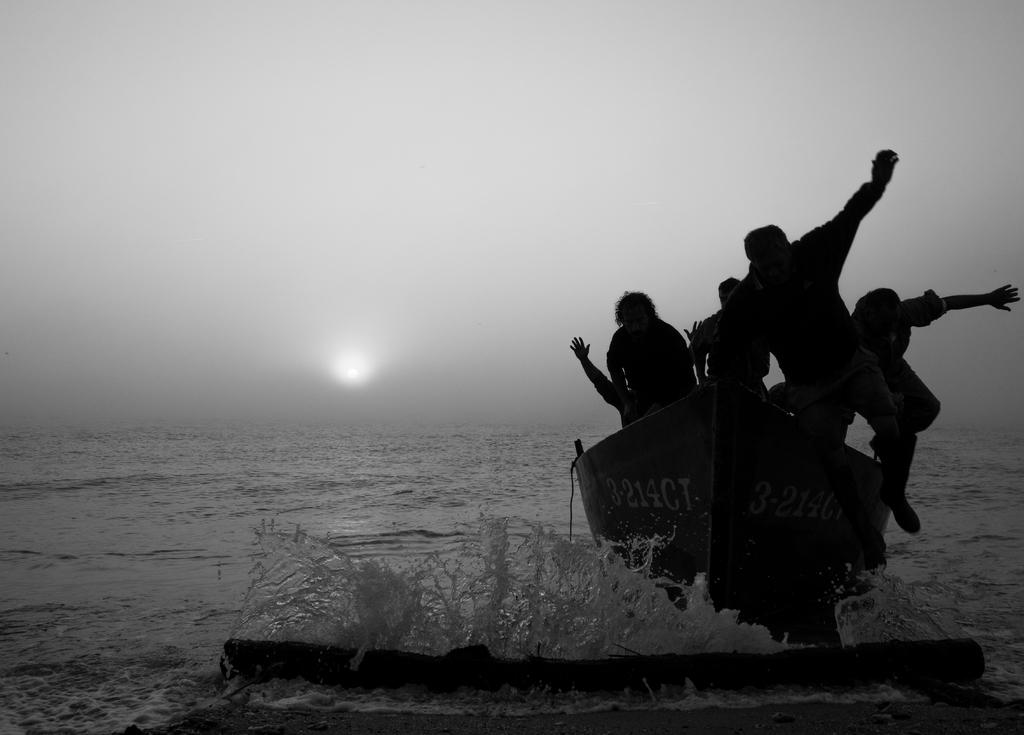What are the people in the image doing? The people are sitting in a boat. Where is the boat located? The boat is in the water. What can be seen in the sky in the image? The sky is visible in the image, and the moon is visible in the sky. What type of plastic material can be seen in the image? There is no plastic material present in the image. How many steps does it take to reach the moon in the image? The image does not depict any steps or actions related to reaching the moon; it simply shows the moon in the sky. 